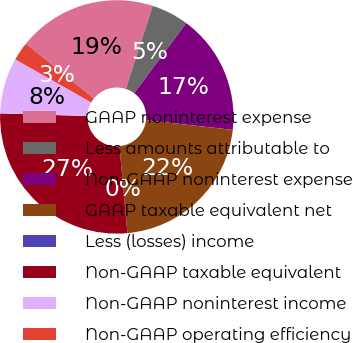Convert chart to OTSL. <chart><loc_0><loc_0><loc_500><loc_500><pie_chart><fcel>GAAP noninterest expense<fcel>Less amounts attributable to<fcel>Non-GAAP noninterest expense<fcel>GAAP taxable equivalent net<fcel>Less (losses) income<fcel>Non-GAAP taxable equivalent<fcel>Non-GAAP noninterest income<fcel>Non-GAAP operating efficiency<nl><fcel>19.2%<fcel>5.15%<fcel>16.63%<fcel>21.78%<fcel>0.0%<fcel>26.93%<fcel>7.73%<fcel>2.58%<nl></chart> 